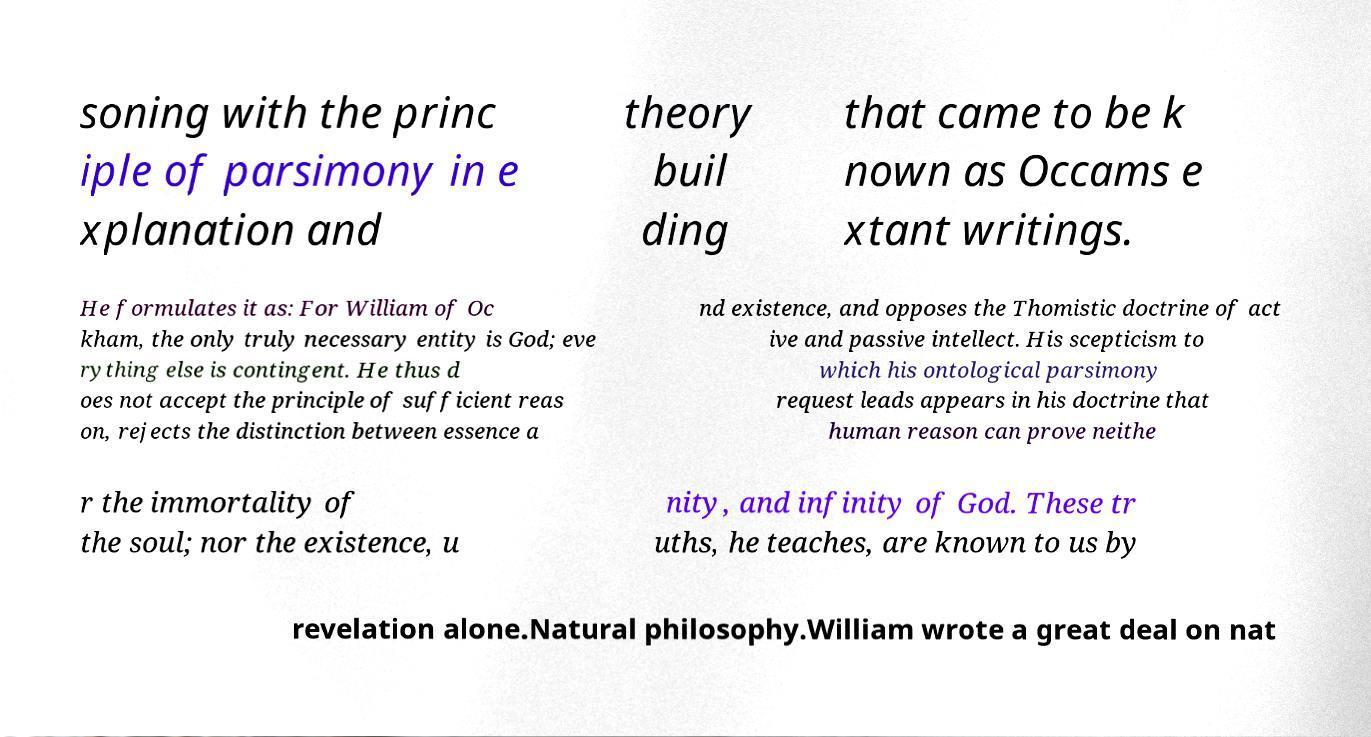Can you accurately transcribe the text from the provided image for me? soning with the princ iple of parsimony in e xplanation and theory buil ding that came to be k nown as Occams e xtant writings. He formulates it as: For William of Oc kham, the only truly necessary entity is God; eve rything else is contingent. He thus d oes not accept the principle of sufficient reas on, rejects the distinction between essence a nd existence, and opposes the Thomistic doctrine of act ive and passive intellect. His scepticism to which his ontological parsimony request leads appears in his doctrine that human reason can prove neithe r the immortality of the soul; nor the existence, u nity, and infinity of God. These tr uths, he teaches, are known to us by revelation alone.Natural philosophy.William wrote a great deal on nat 